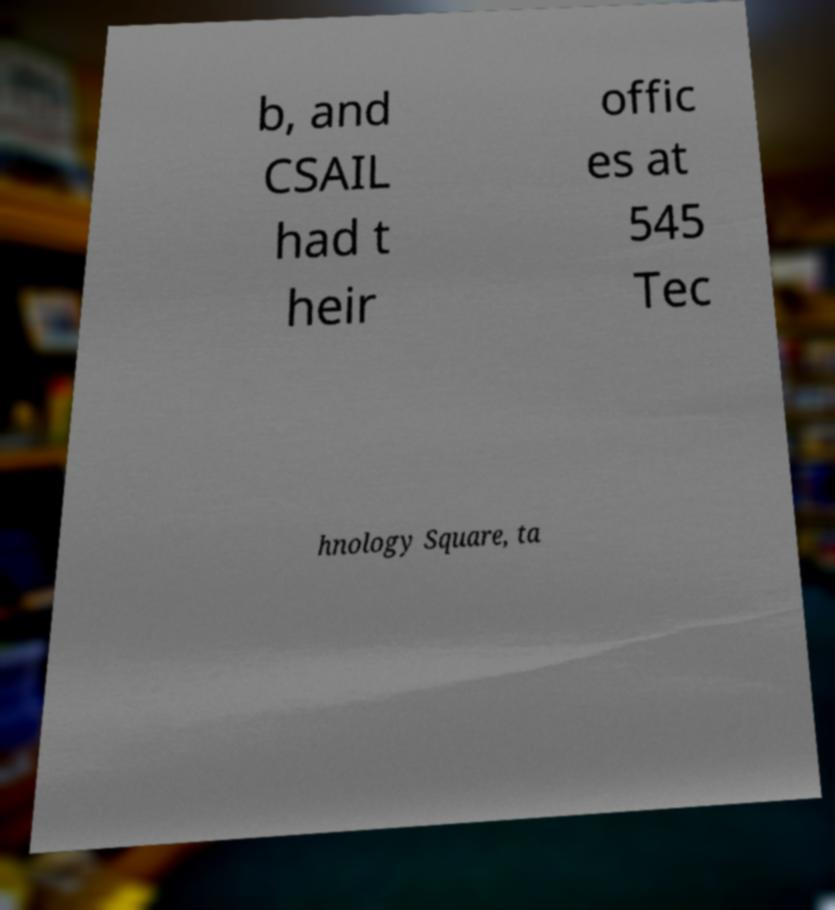Can you accurately transcribe the text from the provided image for me? b, and CSAIL had t heir offic es at 545 Tec hnology Square, ta 